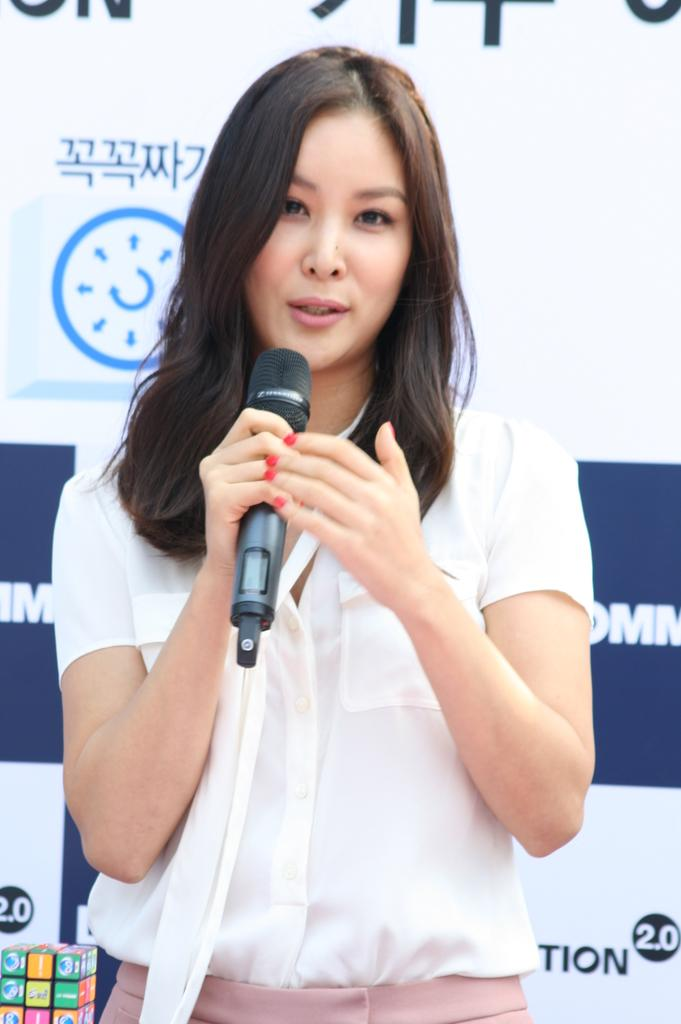What is the gender of the person in the image? The person in the image is a lady. What is the lady person wearing? The lady person is wearing a white dress. What object is the lady person holding? The lady person is holding a microphone. What color is the sheet in the background of the image? The sheet in the background of the image is white. What type of range can be seen in the image? There is no range present in the image. Can you describe the flight in the image? There is no flight depicted in the image. 